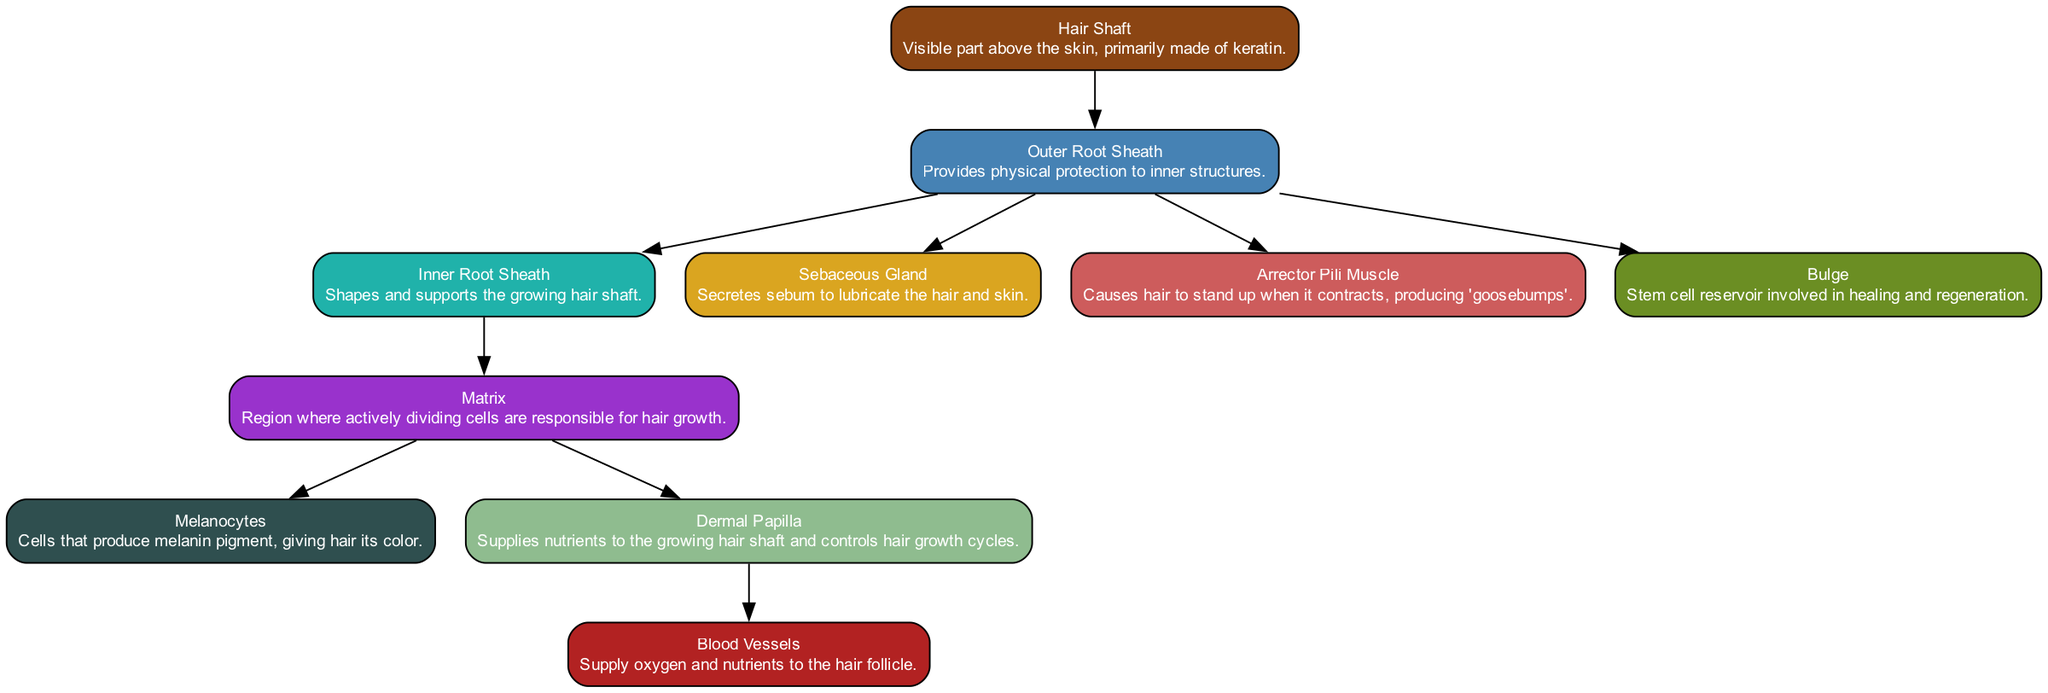What is the visible part of the hair called? The visible part of the hair is labeled as the "Hair Shaft" in the diagram.
Answer: Hair Shaft How many glands are in the hair follicle structure? The diagram shows one "Sebaceous Gland" associated with the hair follicle.
Answer: One What does the Arrector Pili Muscle do? The diagram explains that the Arrector Pili Muscle causes hair to stand up when it contracts, which produces 'goosebumps'.
Answer: Causes hair to stand up Which part supplies nutrients to the hair? The "Dermal Papilla" in the diagram is responsible for supplying nutrients to the growing hair shaft.
Answer: Dermal Papilla Which structures are involved in hair growth? The diagram shows that the "Matrix" plays a key role in actively dividing cells for hair growth, while "Dermal Papilla" also contributes to nutrient supply for hair growth.
Answer: Matrix and Dermal Papilla What component within the hair follicle is responsible for producing melanin? According to the diagram, "Melanocytes" are the cells responsible for producing the melanin pigment that gives hair its color.
Answer: Melanocytes How many layers of the root sheath are there? The diagram indicates there are two layers of root sheaths: "Outer Root Sheath" and "Inner Root Sheath".
Answer: Two Which part serves as a stem cell reservoir? The "Bulge" in the diagram is identified as the stem cell reservoir involved in healing and regeneration.
Answer: Bulge What muscle is associated with the hair follicle? The "Arrector Pili Muscle" is the muscle shown in the diagram that is associated with the hair follicle.
Answer: Arrector Pili Muscle 